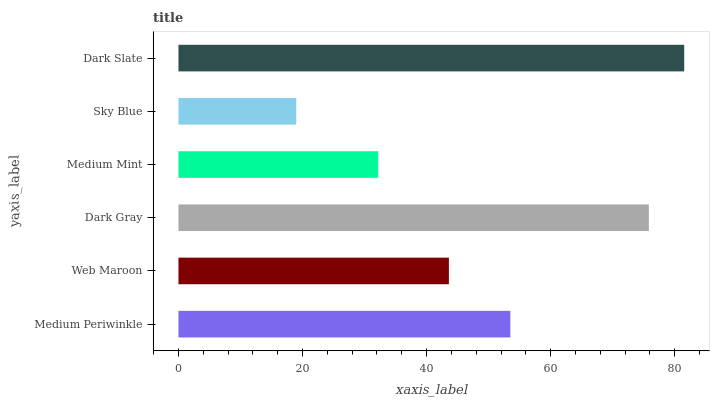Is Sky Blue the minimum?
Answer yes or no. Yes. Is Dark Slate the maximum?
Answer yes or no. Yes. Is Web Maroon the minimum?
Answer yes or no. No. Is Web Maroon the maximum?
Answer yes or no. No. Is Medium Periwinkle greater than Web Maroon?
Answer yes or no. Yes. Is Web Maroon less than Medium Periwinkle?
Answer yes or no. Yes. Is Web Maroon greater than Medium Periwinkle?
Answer yes or no. No. Is Medium Periwinkle less than Web Maroon?
Answer yes or no. No. Is Medium Periwinkle the high median?
Answer yes or no. Yes. Is Web Maroon the low median?
Answer yes or no. Yes. Is Dark Gray the high median?
Answer yes or no. No. Is Medium Periwinkle the low median?
Answer yes or no. No. 